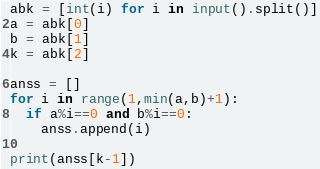Convert code to text. <code><loc_0><loc_0><loc_500><loc_500><_Python_>abk = [int(i) for i in input().split()]
a = abk[0]
b = abk[1]
k = abk[2]

anss = []
for i in range(1,min(a,b)+1):
  if a%i==0 and b%i==0:
    anss.append(i)
    
print(anss[k-1])</code> 